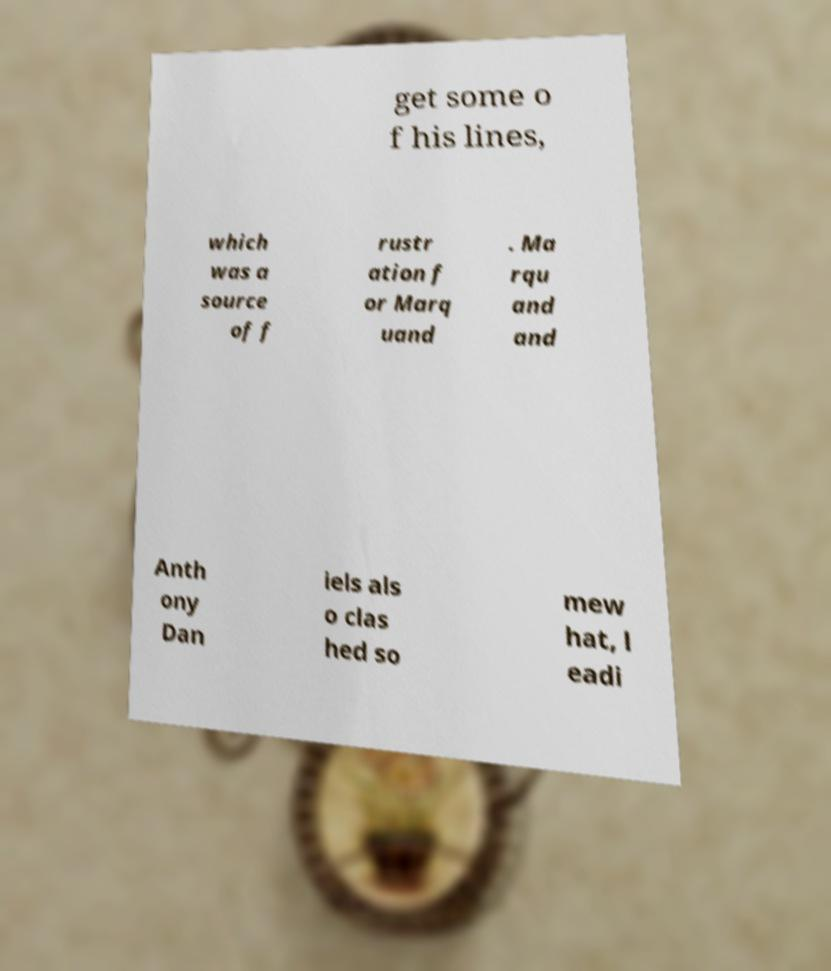Could you assist in decoding the text presented in this image and type it out clearly? get some o f his lines, which was a source of f rustr ation f or Marq uand . Ma rqu and and Anth ony Dan iels als o clas hed so mew hat, l eadi 